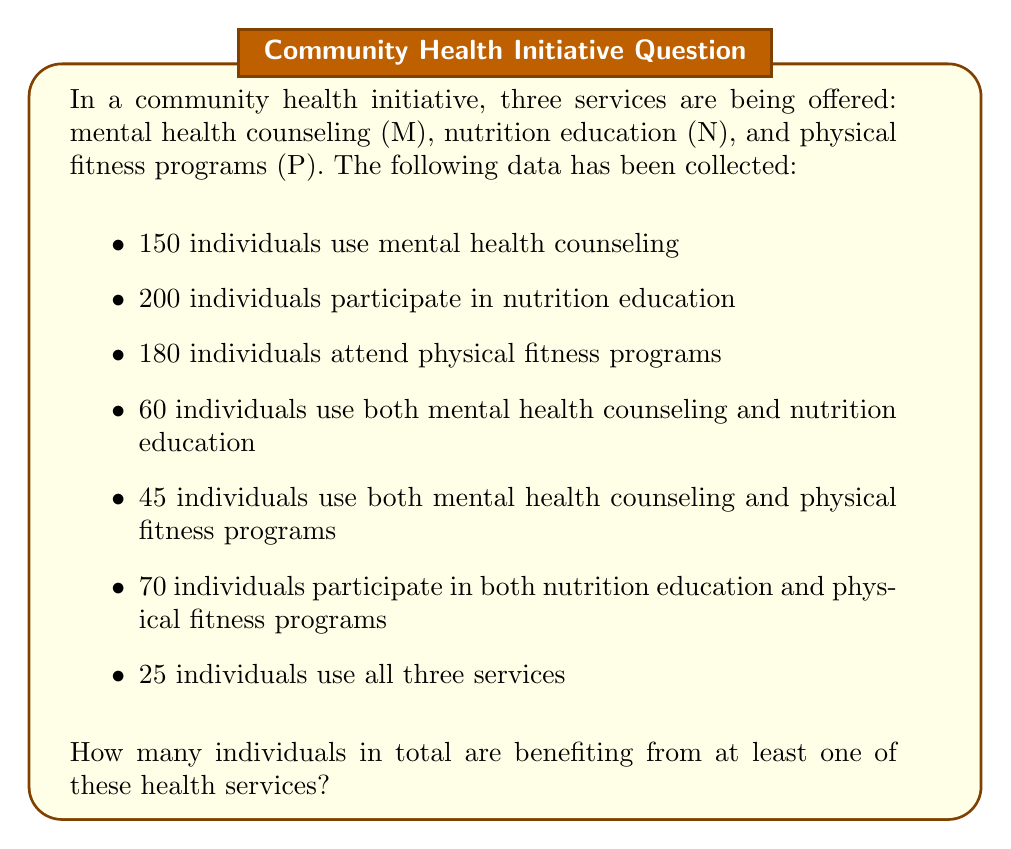Can you answer this question? To solve this problem, we'll apply the principle of inclusion-exclusion. Let's break it down step-by-step:

1) First, let's define our sets:
   M: individuals using mental health counseling
   N: individuals participating in nutrition education
   P: individuals attending physical fitness programs

2) The principle of inclusion-exclusion for three sets is given by:

   $$|M \cup N \cup P| = |M| + |N| + |P| - |M \cap N| - |M \cap P| - |N \cap P| + |M \cap N \cap P|$$

3) We're given:
   $|M| = 150$
   $|N| = 200$
   $|P| = 180$
   $|M \cap N| = 60$
   $|M \cap P| = 45$
   $|N \cap P| = 70$
   $|M \cap N \cap P| = 25$

4) Now, let's substitute these values into our equation:

   $$|M \cup N \cup P| = 150 + 200 + 180 - 60 - 45 - 70 + 25$$

5) Simplify:
   $$|M \cup N \cup P| = 530 - 175 + 25 = 380$$

Therefore, 380 individuals are benefiting from at least one of these health services.
Answer: 380 individuals 